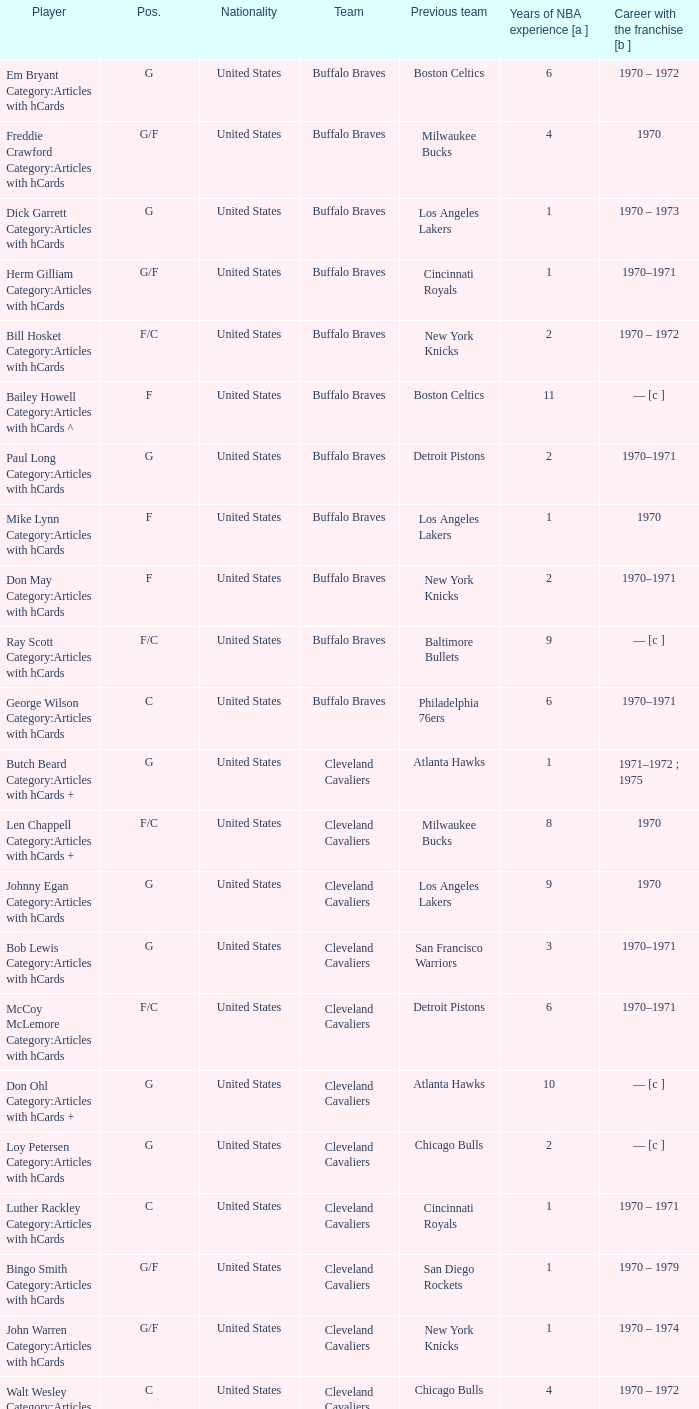Can you give me this table as a dict? {'header': ['Player', 'Pos.', 'Nationality', 'Team', 'Previous team', 'Years of NBA experience [a ]', 'Career with the franchise [b ]'], 'rows': [['Em Bryant Category:Articles with hCards', 'G', 'United States', 'Buffalo Braves', 'Boston Celtics', '6', '1970 – 1972'], ['Freddie Crawford Category:Articles with hCards', 'G/F', 'United States', 'Buffalo Braves', 'Milwaukee Bucks', '4', '1970'], ['Dick Garrett Category:Articles with hCards', 'G', 'United States', 'Buffalo Braves', 'Los Angeles Lakers', '1', '1970 – 1973'], ['Herm Gilliam Category:Articles with hCards', 'G/F', 'United States', 'Buffalo Braves', 'Cincinnati Royals', '1', '1970–1971'], ['Bill Hosket Category:Articles with hCards', 'F/C', 'United States', 'Buffalo Braves', 'New York Knicks', '2', '1970 – 1972'], ['Bailey Howell Category:Articles with hCards ^', 'F', 'United States', 'Buffalo Braves', 'Boston Celtics', '11', '— [c ]'], ['Paul Long Category:Articles with hCards', 'G', 'United States', 'Buffalo Braves', 'Detroit Pistons', '2', '1970–1971'], ['Mike Lynn Category:Articles with hCards', 'F', 'United States', 'Buffalo Braves', 'Los Angeles Lakers', '1', '1970'], ['Don May Category:Articles with hCards', 'F', 'United States', 'Buffalo Braves', 'New York Knicks', '2', '1970–1971'], ['Ray Scott Category:Articles with hCards', 'F/C', 'United States', 'Buffalo Braves', 'Baltimore Bullets', '9', '— [c ]'], ['George Wilson Category:Articles with hCards', 'C', 'United States', 'Buffalo Braves', 'Philadelphia 76ers', '6', '1970–1971'], ['Butch Beard Category:Articles with hCards +', 'G', 'United States', 'Cleveland Cavaliers', 'Atlanta Hawks', '1', '1971–1972 ; 1975'], ['Len Chappell Category:Articles with hCards +', 'F/C', 'United States', 'Cleveland Cavaliers', 'Milwaukee Bucks', '8', '1970'], ['Johnny Egan Category:Articles with hCards', 'G', 'United States', 'Cleveland Cavaliers', 'Los Angeles Lakers', '9', '1970'], ['Bob Lewis Category:Articles with hCards', 'G', 'United States', 'Cleveland Cavaliers', 'San Francisco Warriors', '3', '1970–1971'], ['McCoy McLemore Category:Articles with hCards', 'F/C', 'United States', 'Cleveland Cavaliers', 'Detroit Pistons', '6', '1970–1971'], ['Don Ohl Category:Articles with hCards +', 'G', 'United States', 'Cleveland Cavaliers', 'Atlanta Hawks', '10', '— [c ]'], ['Loy Petersen Category:Articles with hCards', 'G', 'United States', 'Cleveland Cavaliers', 'Chicago Bulls', '2', '— [c ]'], ['Luther Rackley Category:Articles with hCards', 'C', 'United States', 'Cleveland Cavaliers', 'Cincinnati Royals', '1', '1970 – 1971'], ['Bingo Smith Category:Articles with hCards', 'G/F', 'United States', 'Cleveland Cavaliers', 'San Diego Rockets', '1', '1970 – 1979'], ['John Warren Category:Articles with hCards', 'G/F', 'United States', 'Cleveland Cavaliers', 'New York Knicks', '1', '1970 – 1974'], ['Walt Wesley Category:Articles with hCards', 'C', 'United States', 'Cleveland Cavaliers', 'Chicago Bulls', '4', '1970 – 1972'], ['Rick Adelman Category:Articles with hCards', 'G', 'United States', 'Portland Trail Blazers', 'San Diego Rockets', '2', '1970 – 1973'], ['Jerry Chambers Category:Articles with hCards', 'F', 'United States', 'Portland Trail Blazers', 'Phoenix Suns', '2', '— [c ]'], ['LeRoy Ellis Category:Articles with hCards', 'F/C', 'United States', 'Portland Trail Blazers', 'Baltimore Bullets', '8', '1970–1971'], ['Fred Hetzel Category:Articles with hCards', 'F/C', 'United States', 'Portland Trail Blazers', 'Philadelphia 76ers', '5', '— [c ]'], ['Joe Kennedy Category:Articles with hCards', 'F', 'United States', 'Portland Trail Blazers', 'Seattle SuperSonics', '2', '— [c ]'], ['Ed Manning Category:Articles with hCards', 'F', 'United States', 'Portland Trail Blazers', 'Chicago Bulls', '3', '1970–1971'], ['Stan McKenzie Category:Articles with hCards', 'G/F', 'United States', 'Portland Trail Blazers', 'Phoenix Suns', '3', '1970 – 1972'], ['Dorie Murrey Category:Articles with hCards', 'F/C', 'United States', 'Portland Trail Blazers', 'Seattle SuperSonics', '4', '1970'], ['Pat Riley Category:Articles with hCards', 'G/F', 'United States', 'Portland Trail Blazers', 'San Diego Rockets', '3', '— [c ]'], ['Dale Schlueter Category:Articles with hCards', 'C', 'United States', 'Portland Trail Blazers', 'San Francisco Warriors', '2', '1970 – 1972 ; 1977–1978'], ['Larry Siegfried Category:Articles with hCards', 'F', 'United States', 'Portland Trail Blazers', 'Boston Celtics', '7', '— [c ]']]} How many years of NBA experience does the player who plays position g for the Portland Trail Blazers? 2.0. 